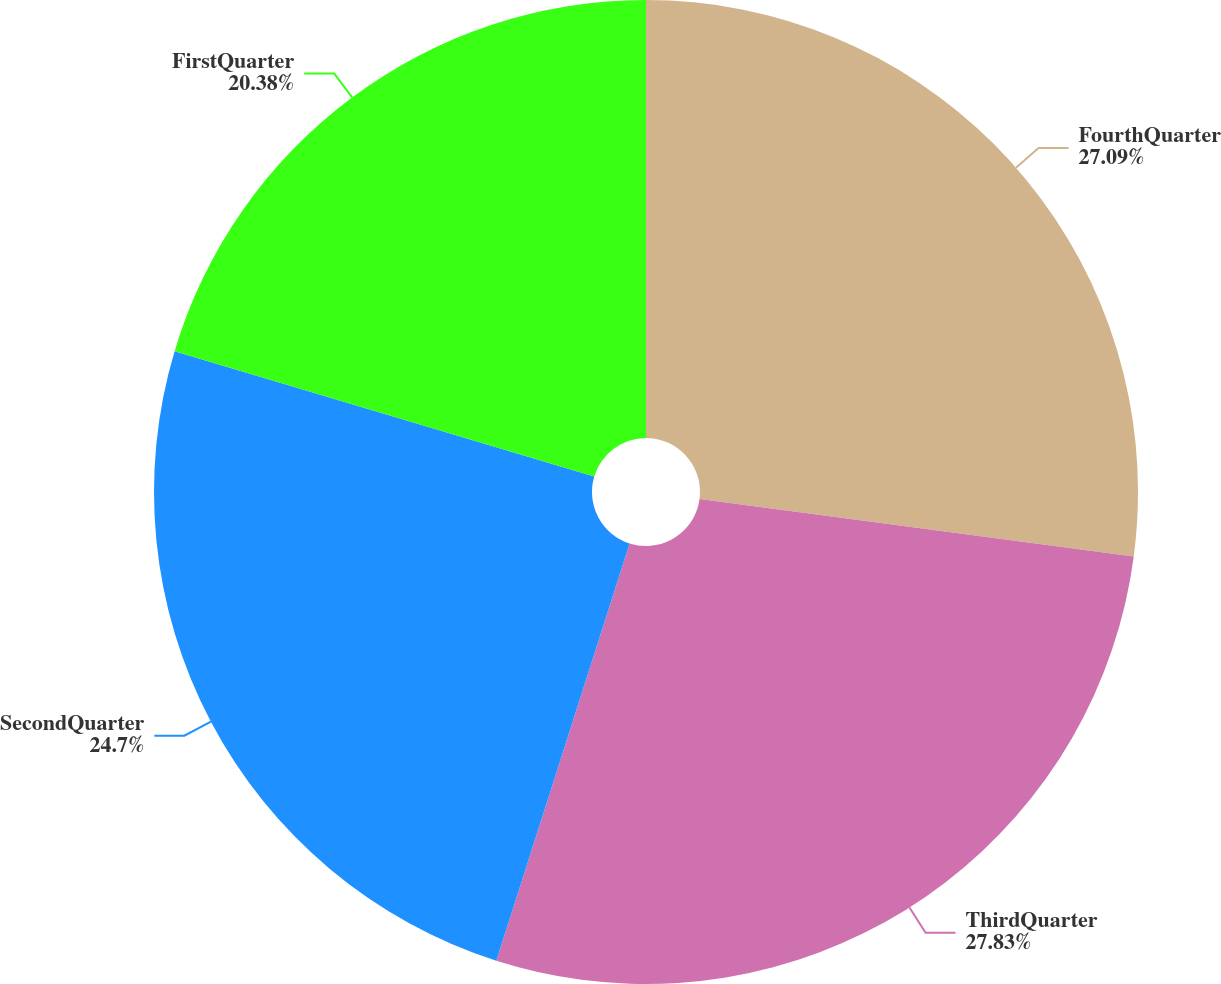Convert chart. <chart><loc_0><loc_0><loc_500><loc_500><pie_chart><fcel>FourthQuarter<fcel>ThirdQuarter<fcel>SecondQuarter<fcel>FirstQuarter<nl><fcel>27.09%<fcel>27.83%<fcel>24.7%<fcel>20.38%<nl></chart> 